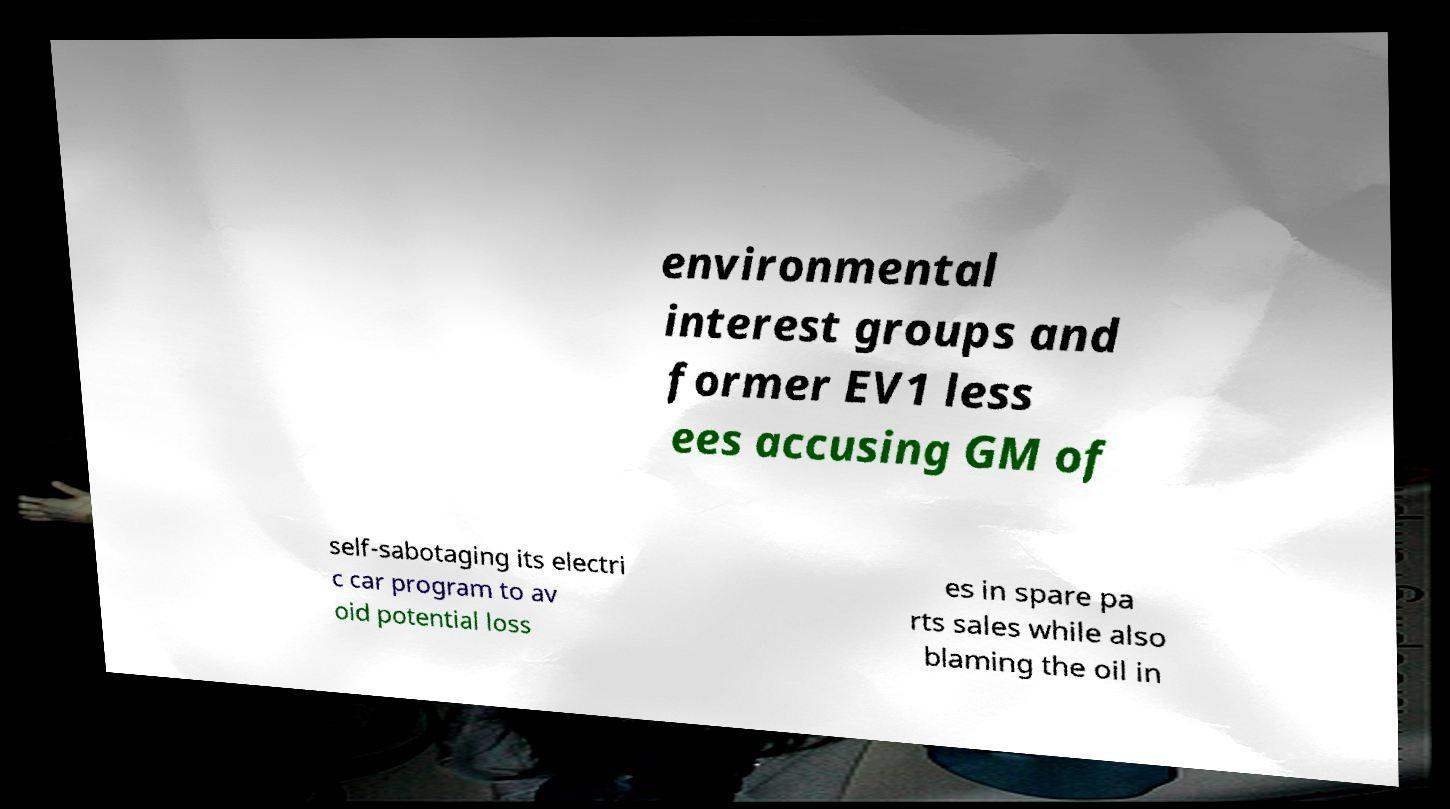Could you extract and type out the text from this image? environmental interest groups and former EV1 less ees accusing GM of self-sabotaging its electri c car program to av oid potential loss es in spare pa rts sales while also blaming the oil in 